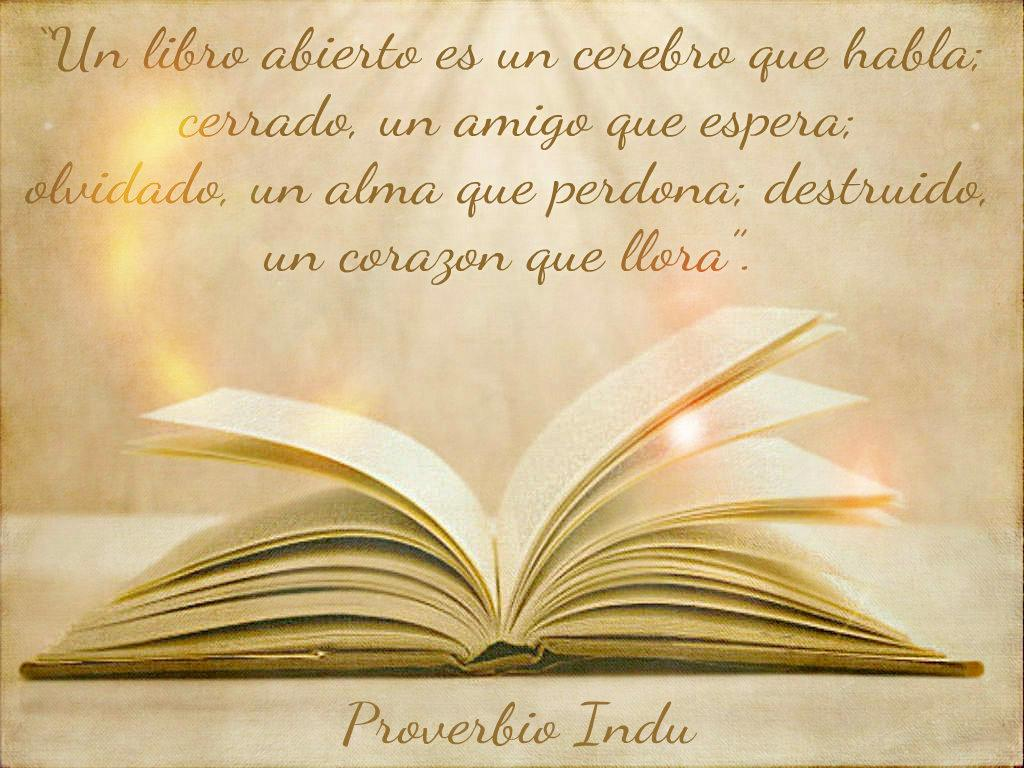<image>
Share a concise interpretation of the image provided. Book with flaring pages that has written in gold Proverbio Indu. 